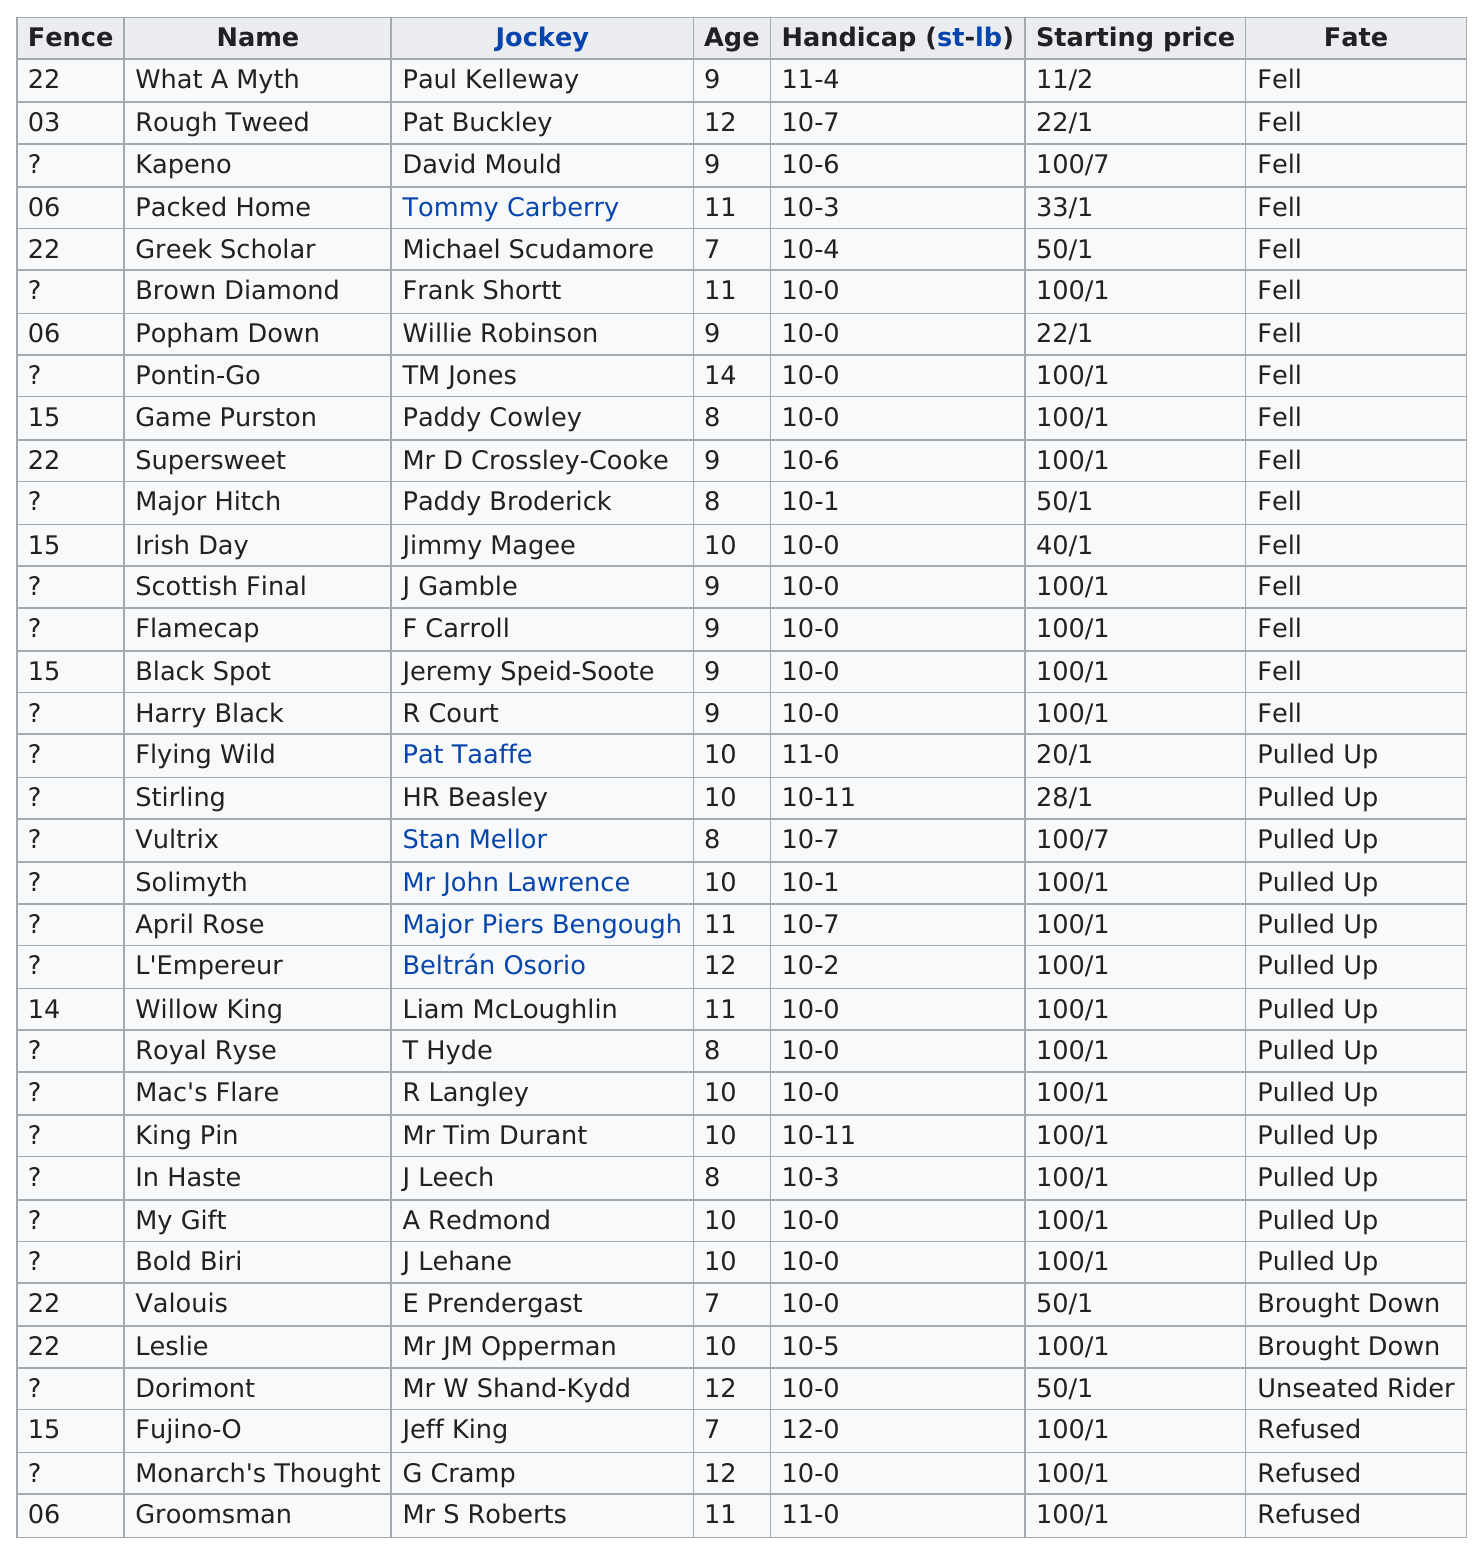List a handful of essential elements in this visual. The question asks for the number of horses that are more than 10 years old. The first fence listed in the chart is number 22. There are 17 horses with a 10-0 handicap. It is declared that the jockey before TM Jones is Willie Robinson. Paul Kelly is the first jockey listed on the chart. 